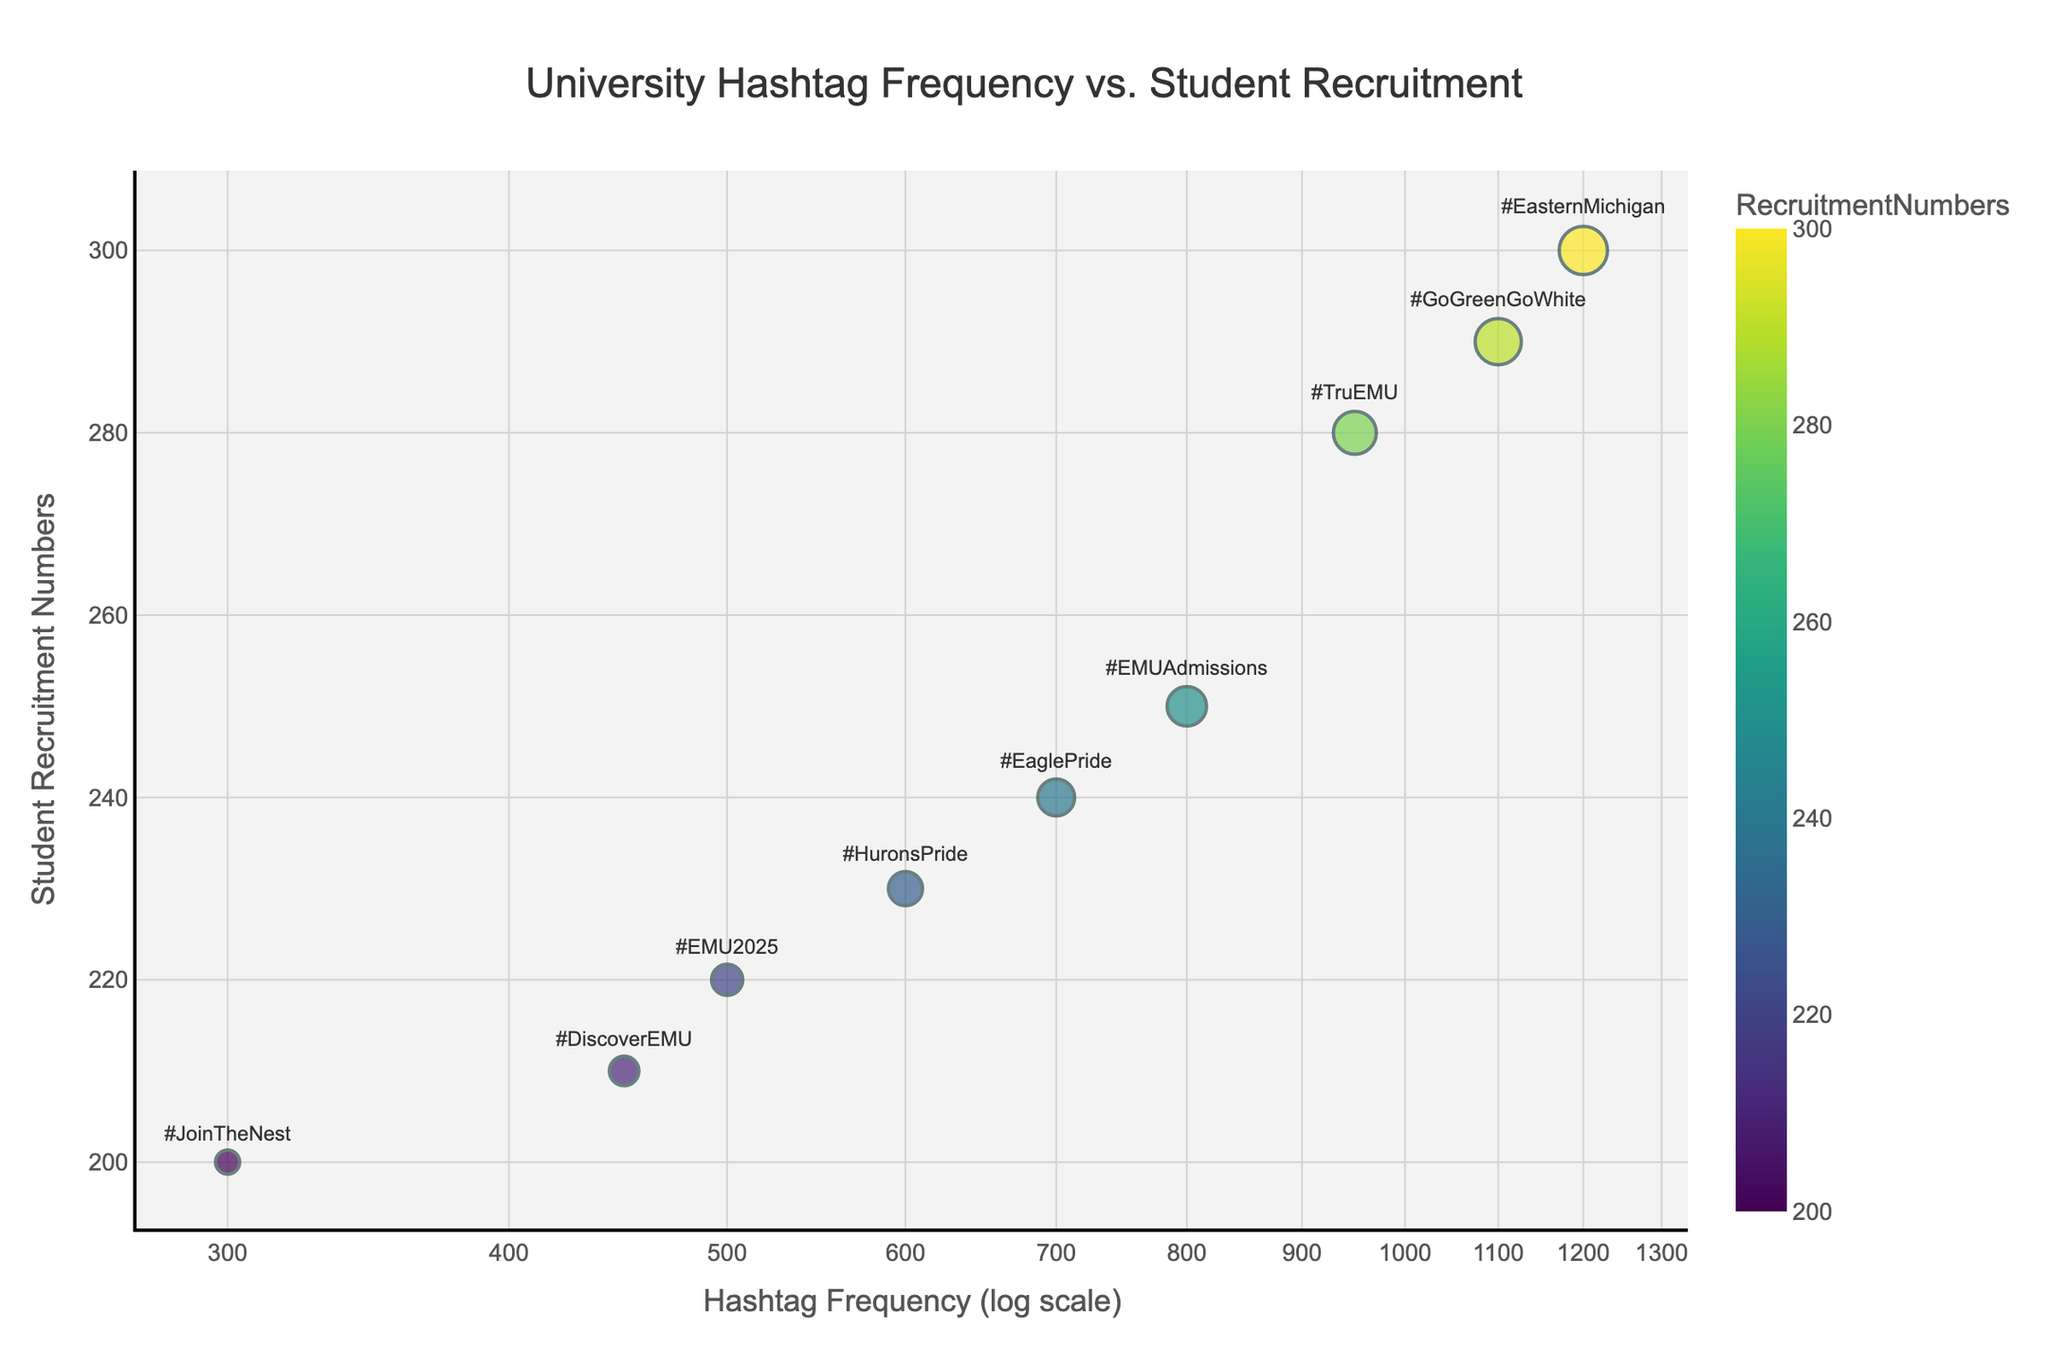What is the title of the scatter plot? The title of the scatter plot is usually displayed prominently at the top of the chart. It should be easy to read and directly indicates what the chart is about.
Answer: University Hashtag Frequency vs. Student Recruitment How many hashtag data points are displayed in the scatter plot? By counting the number of distinct markers or points on the scatter plot, we can determine the number of hashtag data points.
Answer: 9 Which hashtag has the highest frequency? Identify the marker positioned furthest to the right on the x-axis since higher frequency values are plotted to the right on a log scale.
Answer: #EasternMichigan Which hashtag has the lowest student recruitment numbers? Identify the marker that is positioned lowest on the y-axis because lower recruitment numbers are plotted lower on the graph.
Answer: #JoinTheNest What is the range of student recruitment numbers displayed in the scatter plot? By examining the y-axis, we can observe the minimum and maximum values. The minimum value appears near the lowest data point, and the maximum value appears near the highest data point.
Answer: 200-300 How does the recruitment number of #TruEMU compare to #DiscoverEMU? Check the y-axis positions for both hashtags. #TruEMU is higher than #DiscoverEMU, indicating #TruEMU has higher recruitment numbers.
Answer: #TruEMU has higher recruitment numbers What is the approximate student recruitment number for the hashtag with 1,100 in frequency? Find the marker with an x-axis value of approximately 1,100 and read its y-axis value to estimate student recruitment numbers.
Answer: ~290 Which hashtag has a frequency between 400 and 600 and above 220 in student recruitment numbers? Look for markers positioned within the specified x-axis (frequency) range and above the specified y-axis (student recruitment) threshold.
Answer: #EMU2025 What could be a possible relationship between hashtag frequency and student recruitment numbers? Examine the overall pattern of the plot to deduce possible trends. Observing the general direction of data point distributions can indicate correlations.
Answer: Positive correlation (higher frequency generally correlates with higher recruitment) If a hashtag's frequency doubles, can we expect its student recruitment numbers to double too? Analyze the overall trend and relationship between variables in the scatter plot; note that such a relationship isn’t strictly linear in the given data.
Answer: Not necessarily 